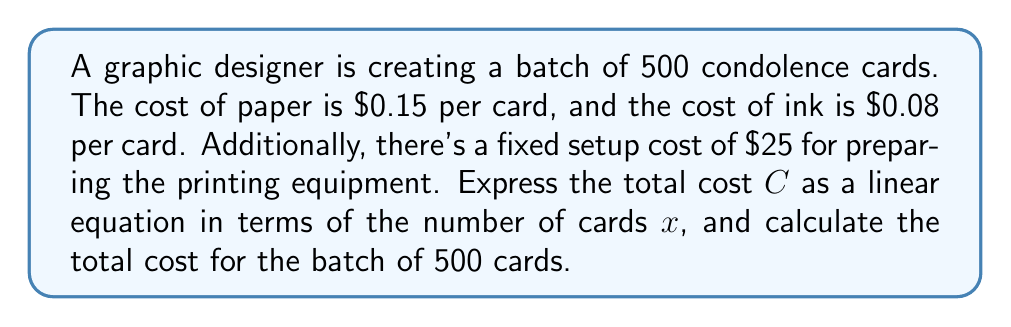Provide a solution to this math problem. 1) Let's define our variables:
   $x$ = number of cards
   $C$ = total cost

2) We can express the cost per card as:
   Paper cost per card: $0.15
   Ink cost per card: $0.08
   Total variable cost per card: $0.15 + 0.08 = 0.23$

3) The fixed cost is $25 for setup.

4) Now we can form a linear equation:
   $C = 0.23x + 25$

   Where $0.23x$ represents the variable cost for $x$ cards, and 25 is the fixed cost.

5) To find the total cost for 500 cards, we substitute $x = 500$:

   $C = 0.23(500) + 25$
   $C = 115 + 25$
   $C = 140$

Therefore, the total cost for 500 cards is $140.
Answer: $C = 0.23x + 25$; $140 